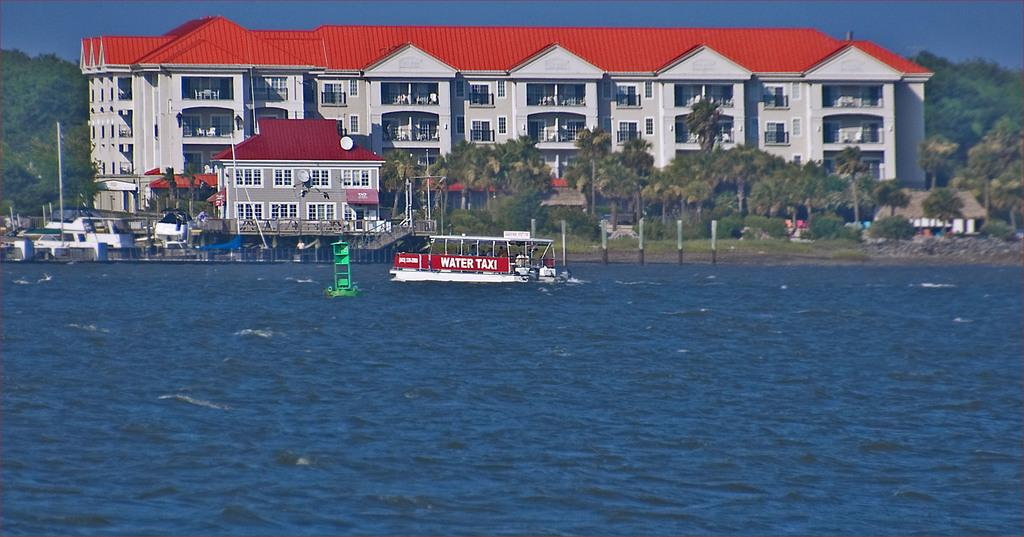What is the main subject of the image? The main subject of the image is a boat. Where is the boat located? The boat is on the water. What can be seen in the background of the image? In the background of the image, there are buildings, trees, poles, stairs, sheds, and benches. What is visible at the top of the image? The sky is visible at the top of the image. What type of music is being played by the group in the image? There is no group or music present in the image; it features a boat on the water with various background elements. 